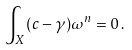<formula> <loc_0><loc_0><loc_500><loc_500>\int _ { X } ( c - \gamma ) \omega ^ { n } = 0 \, .</formula> 